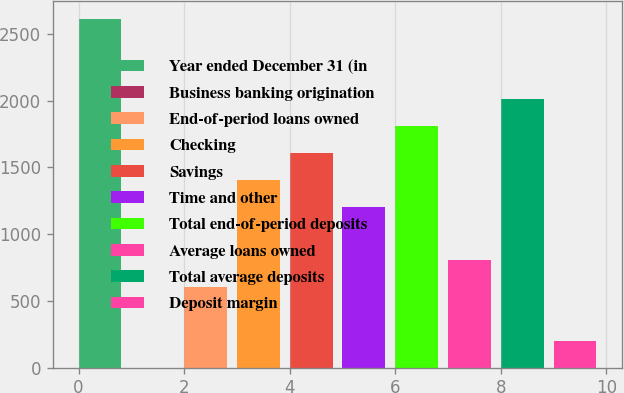Convert chart. <chart><loc_0><loc_0><loc_500><loc_500><bar_chart><fcel>Year ended December 31 (in<fcel>Business banking origination<fcel>End-of-period loans owned<fcel>Checking<fcel>Savings<fcel>Time and other<fcel>Total end-of-period deposits<fcel>Average loans owned<fcel>Total average deposits<fcel>Deposit margin<nl><fcel>2611.01<fcel>2.3<fcel>604.31<fcel>1406.99<fcel>1607.66<fcel>1206.32<fcel>1808.33<fcel>804.98<fcel>2009<fcel>202.97<nl></chart> 